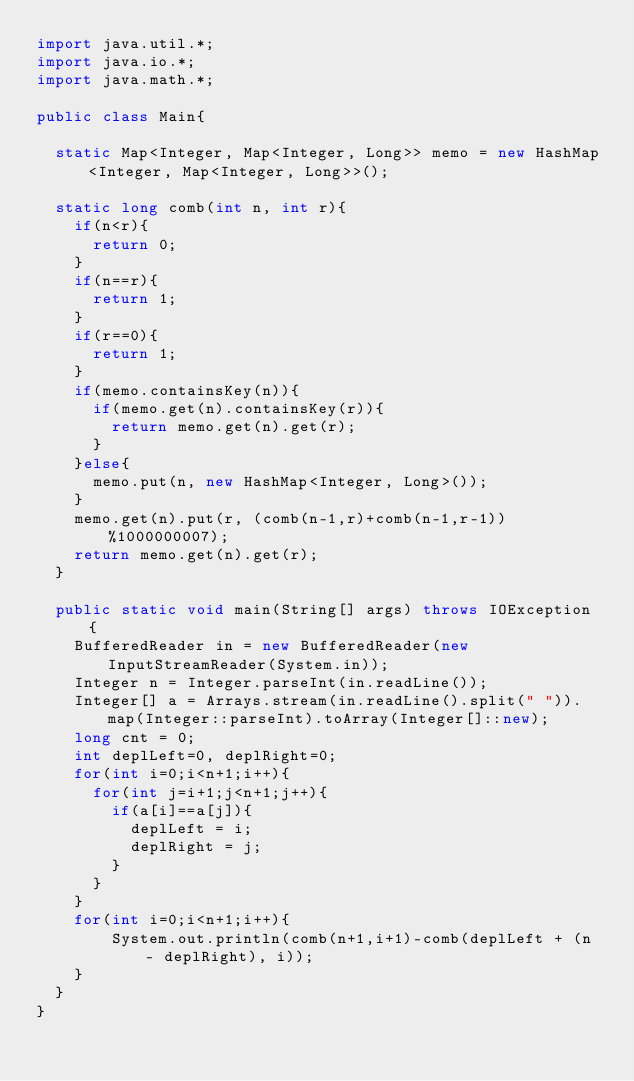<code> <loc_0><loc_0><loc_500><loc_500><_Java_>import java.util.*;
import java.io.*;
import java.math.*;

public class Main{

  static Map<Integer, Map<Integer, Long>> memo = new HashMap<Integer, Map<Integer, Long>>();

  static long comb(int n, int r){
    if(n<r){
      return 0;
    }
    if(n==r){
      return 1;
    }
    if(r==0){
      return 1;
    }
    if(memo.containsKey(n)){
      if(memo.get(n).containsKey(r)){
        return memo.get(n).get(r);
      }
    }else{
      memo.put(n, new HashMap<Integer, Long>());
    }
    memo.get(n).put(r, (comb(n-1,r)+comb(n-1,r-1))%1000000007);
    return memo.get(n).get(r);
  }

  public static void main(String[] args) throws IOException {
    BufferedReader in = new BufferedReader(new InputStreamReader(System.in));
    Integer n = Integer.parseInt(in.readLine());
    Integer[] a = Arrays.stream(in.readLine().split(" ")).map(Integer::parseInt).toArray(Integer[]::new);
    long cnt = 0;
    int deplLeft=0, deplRight=0;
    for(int i=0;i<n+1;i++){
      for(int j=i+1;j<n+1;j++){
        if(a[i]==a[j]){
          deplLeft = i;
          deplRight = j;
        }
      }
    }
    for(int i=0;i<n+1;i++){
        System.out.println(comb(n+1,i+1)-comb(deplLeft + (n - deplRight), i));
    }
  }
}
</code> 